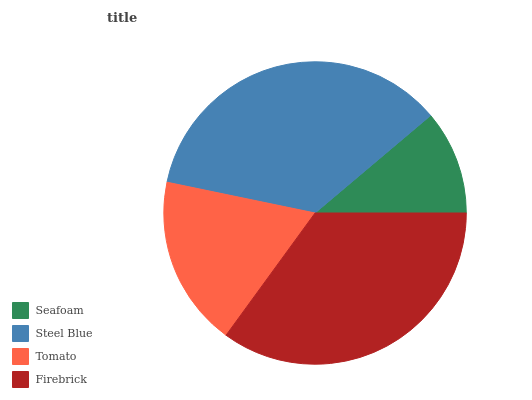Is Seafoam the minimum?
Answer yes or no. Yes. Is Steel Blue the maximum?
Answer yes or no. Yes. Is Tomato the minimum?
Answer yes or no. No. Is Tomato the maximum?
Answer yes or no. No. Is Steel Blue greater than Tomato?
Answer yes or no. Yes. Is Tomato less than Steel Blue?
Answer yes or no. Yes. Is Tomato greater than Steel Blue?
Answer yes or no. No. Is Steel Blue less than Tomato?
Answer yes or no. No. Is Firebrick the high median?
Answer yes or no. Yes. Is Tomato the low median?
Answer yes or no. Yes. Is Seafoam the high median?
Answer yes or no. No. Is Firebrick the low median?
Answer yes or no. No. 